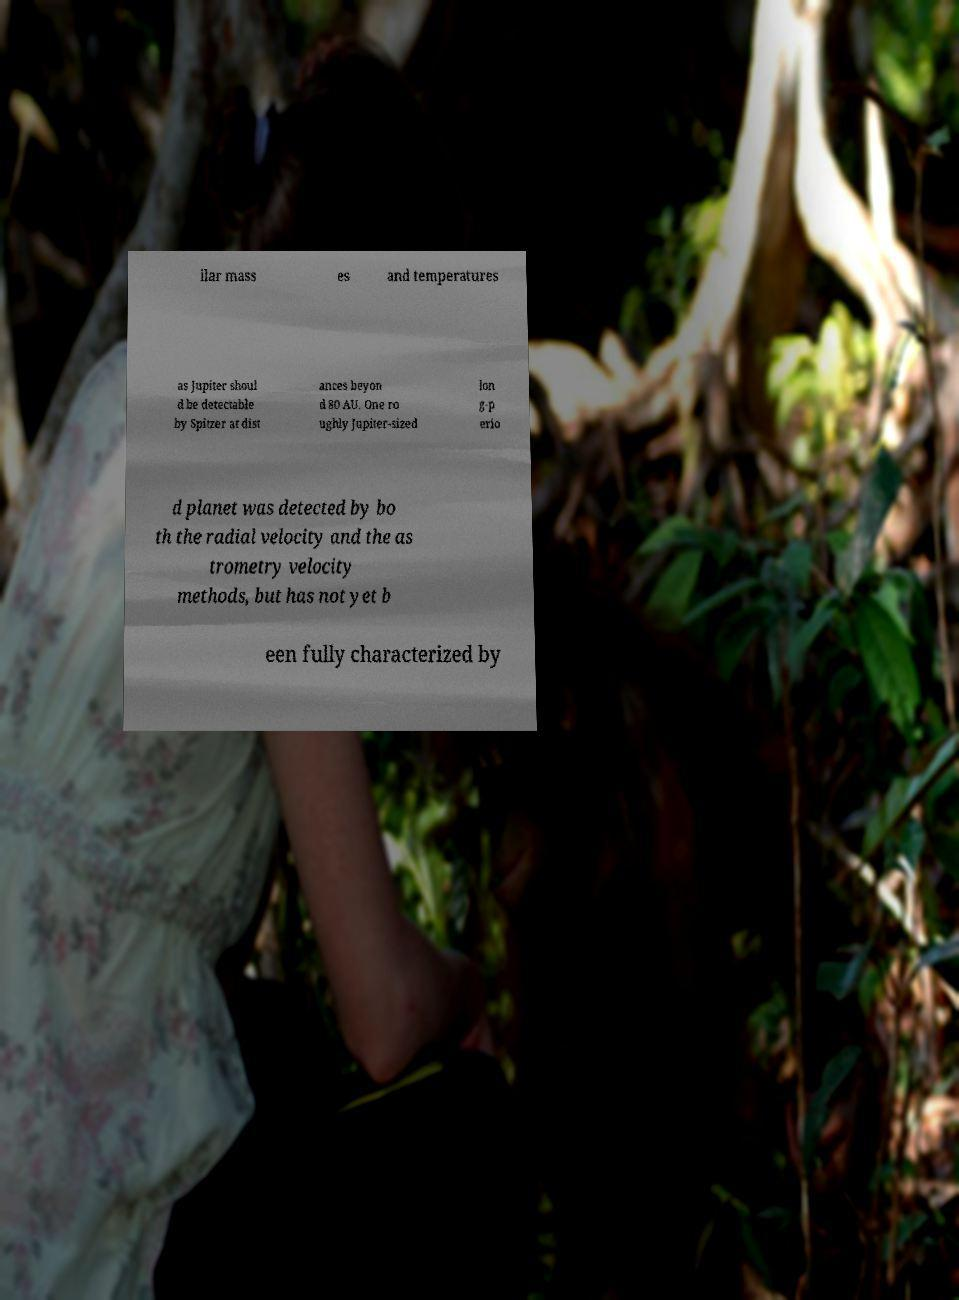Could you assist in decoding the text presented in this image and type it out clearly? ilar mass es and temperatures as Jupiter shoul d be detectable by Spitzer at dist ances beyon d 80 AU. One ro ughly Jupiter-sized lon g-p erio d planet was detected by bo th the radial velocity and the as trometry velocity methods, but has not yet b een fully characterized by 